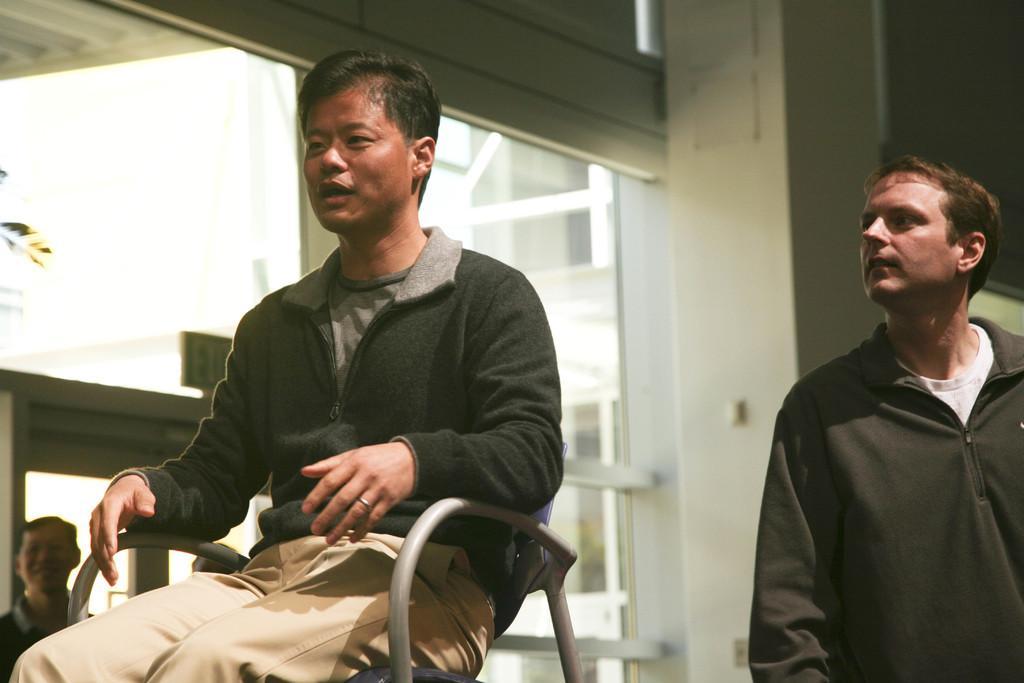Can you describe this image briefly? Man in green jacket is sitting on chair and he is trying to talk something. Man on the left right corner of the picture is looking the man sitting on chair. Behind them, we see a pillar which is white in color and we even see windows from which buildings are visible. On left bottom, we see man smiling. 